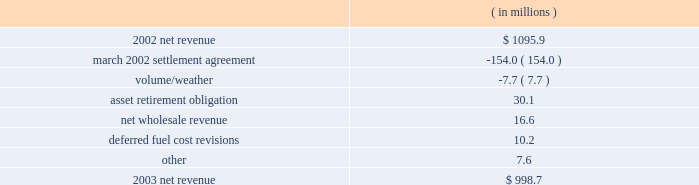Entergy arkansas , inc .
Management's financial discussion and analysis fuel and purchased power expenses increased primarily due to increased recovery of deferred fuel and purchased power costs primarily due to an increase in april 2004 in the energy cost recovery rider and the true-ups to the 2003 and 2002 energy cost recovery rider filings .
Other regulatory credits decreased primarily due to the over-recovery of grand gulf costs due to an increase in the grand gulf rider effective january 2004 .
2003 compared to 2002 net revenue , which is entergy arkansas' measure of gross margin , consists of operating revenues net of : 1 ) fuel , fuel-related , and purchased power expenses and 2 ) other regulatory credits .
Following is an analysis of the change in net revenue comparing 2003 to 2002. .
The march 2002 settlement agreement resolved a request for recovery of ice storm costs incurred in december 2000 with an offset of those costs for funds contributed to pay for future stranded costs .
A 1997 settlement provided for the collection of earnings in excess of an 11% ( 11 % ) return on equity in a transition cost account ( tca ) to offset stranded costs if retail open access were implemented .
In mid- and late december 2000 , two separate ice storms left 226000 and 212500 entergy arkansas customers , respectively , without electric power in its service area .
Entergy arkansas filed a proposal to recover costs plus carrying charges associated with power restoration caused by the ice storms .
Entergy arkansas' final storm damage cost determination reflected costs of approximately $ 195 million .
The apsc approved a settlement agreement submitted in march 2002 by entergy arkansas , the apsc staff , and the arkansas attorney general .
In the march 2002 settlement , the parties agreed that $ 153 million of the ice storm costs would be classified as incremental ice storm expenses that can be offset against the tca on a rate class basis , and any excess of ice storm costs over the amount available in the tca would be deferred and amortized over 30 years , although such excess costs were not allowed to be included as a separate component of rate base .
The allocated ice storm expenses exceeded the available tca funds by $ 15.8 million which was recorded as a regulatory asset in june 2002 .
In accordance with the settlement agreement and following the apsc's approval of the 2001 earnings review related to the tca , entergy arkansas filed to return $ 18.1 million of the tca to certain large general service class customers that paid more into the tca than their allocation of storm costs .
The apsc approved the return of funds to the large general service customer class in the form of refund checks in august 2002 .
As part of the implementation of the march 2002 settlement agreement provisions , the tca procedure ceased with the 2001 earnings evaluation .
Of the remaining ice storm costs , $ 32.2 million was addressed through established ratemaking procedures , including $ 22.2 million classified as capital additions , while $ 3.8 million of the ice storm costs was not recovered through rates .
The effect on net income of the march 2002 settlement agreement and 2001 earnings review was a $ 2.2 million increase in 2003 , because the decrease in net revenue was offset by the decrease in operation and maintenance expenses discussed below. .
What is the storm damage cost as a percentage of 2002 net revenue? 
Computations: (195 / 1095.9)
Answer: 0.17794. 